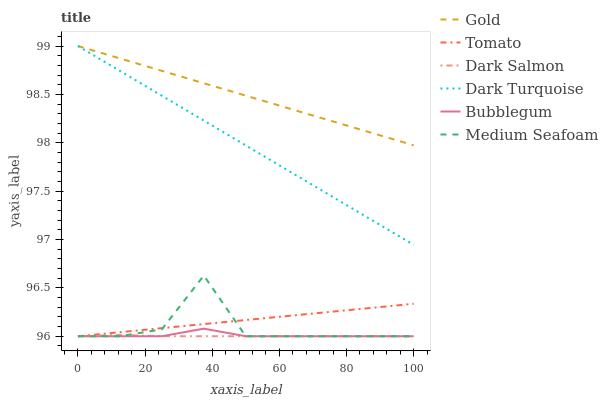Does Dark Salmon have the minimum area under the curve?
Answer yes or no. Yes. Does Gold have the maximum area under the curve?
Answer yes or no. Yes. Does Dark Turquoise have the minimum area under the curve?
Answer yes or no. No. Does Dark Turquoise have the maximum area under the curve?
Answer yes or no. No. Is Dark Turquoise the smoothest?
Answer yes or no. Yes. Is Medium Seafoam the roughest?
Answer yes or no. Yes. Is Gold the smoothest?
Answer yes or no. No. Is Gold the roughest?
Answer yes or no. No. Does Tomato have the lowest value?
Answer yes or no. Yes. Does Dark Turquoise have the lowest value?
Answer yes or no. No. Does Dark Turquoise have the highest value?
Answer yes or no. Yes. Does Dark Salmon have the highest value?
Answer yes or no. No. Is Dark Salmon less than Dark Turquoise?
Answer yes or no. Yes. Is Dark Turquoise greater than Dark Salmon?
Answer yes or no. Yes. Does Dark Salmon intersect Medium Seafoam?
Answer yes or no. Yes. Is Dark Salmon less than Medium Seafoam?
Answer yes or no. No. Is Dark Salmon greater than Medium Seafoam?
Answer yes or no. No. Does Dark Salmon intersect Dark Turquoise?
Answer yes or no. No. 